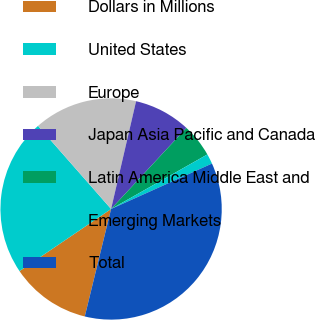<chart> <loc_0><loc_0><loc_500><loc_500><pie_chart><fcel>Dollars in Millions<fcel>United States<fcel>Europe<fcel>Japan Asia Pacific and Canada<fcel>Latin America Middle East and<fcel>Emerging Markets<fcel>Total<nl><fcel>11.69%<fcel>23.02%<fcel>15.1%<fcel>8.29%<fcel>4.88%<fcel>1.47%<fcel>35.56%<nl></chart> 